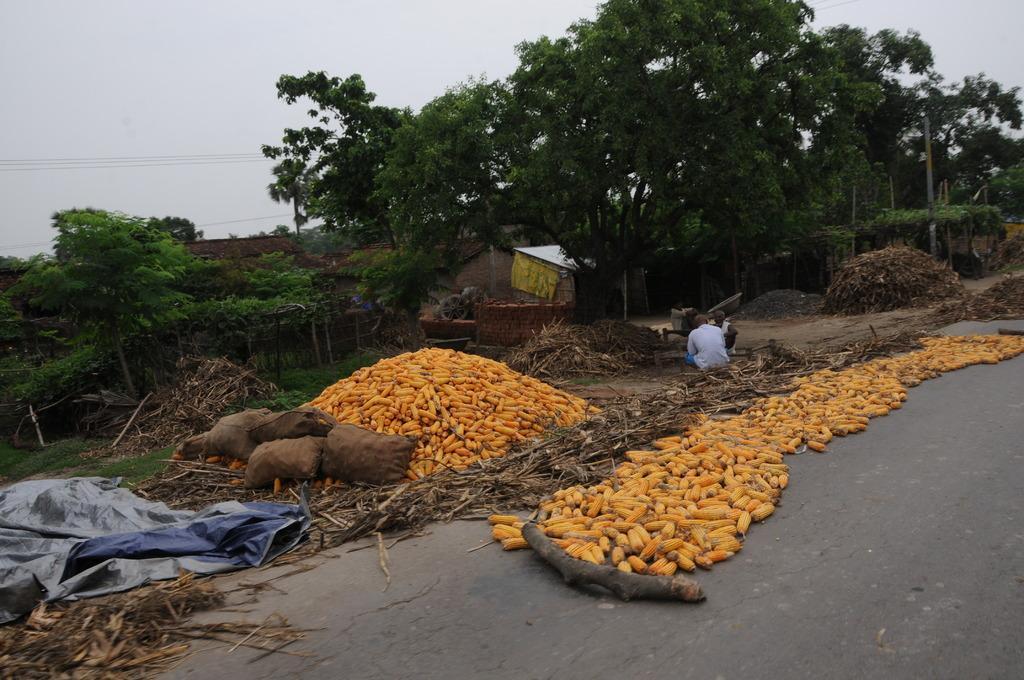Describe this image in one or two sentences. In this image, we can see some trees and corns. There is a tarpaulin in the bottom left of the image. There are roof houses and wooden waste in the middle of the image. There is a road at the bottom of the image. At the top of the image, we can see the sky. 